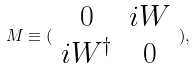<formula> <loc_0><loc_0><loc_500><loc_500>M \equiv ( \begin{array} { c c } 0 & i W \\ i W ^ { \dagger } & 0 \end{array} ) ,</formula> 